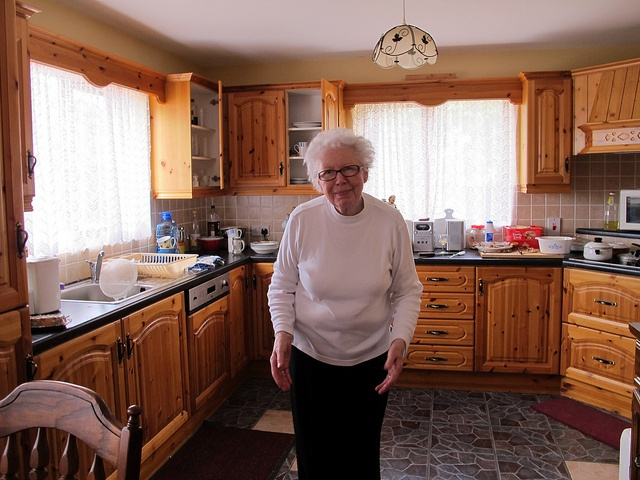Describe the objects in this image and their specific colors. I can see people in maroon, black, and gray tones, chair in maroon, black, gray, and brown tones, sink in maroon, darkgray, gray, and lavender tones, oven in maroon, black, and gray tones, and microwave in maroon, darkgray, black, and gray tones in this image. 